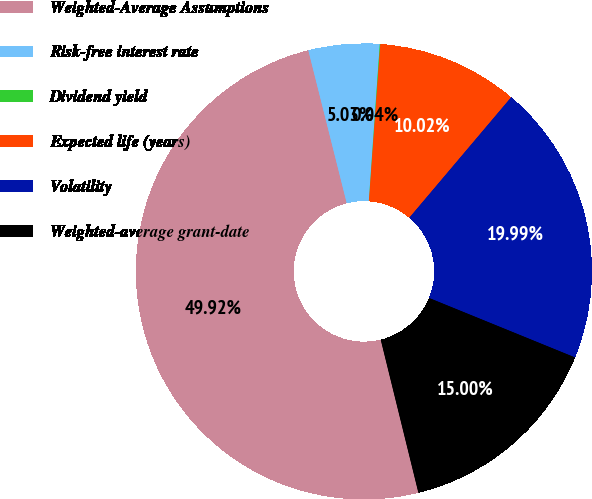Convert chart. <chart><loc_0><loc_0><loc_500><loc_500><pie_chart><fcel>Weighted-Average Assumptions<fcel>Risk-free interest rate<fcel>Dividend yield<fcel>Expected life (years)<fcel>Volatility<fcel>Weighted-average grant-date<nl><fcel>49.92%<fcel>5.03%<fcel>0.04%<fcel>10.02%<fcel>19.99%<fcel>15.0%<nl></chart> 